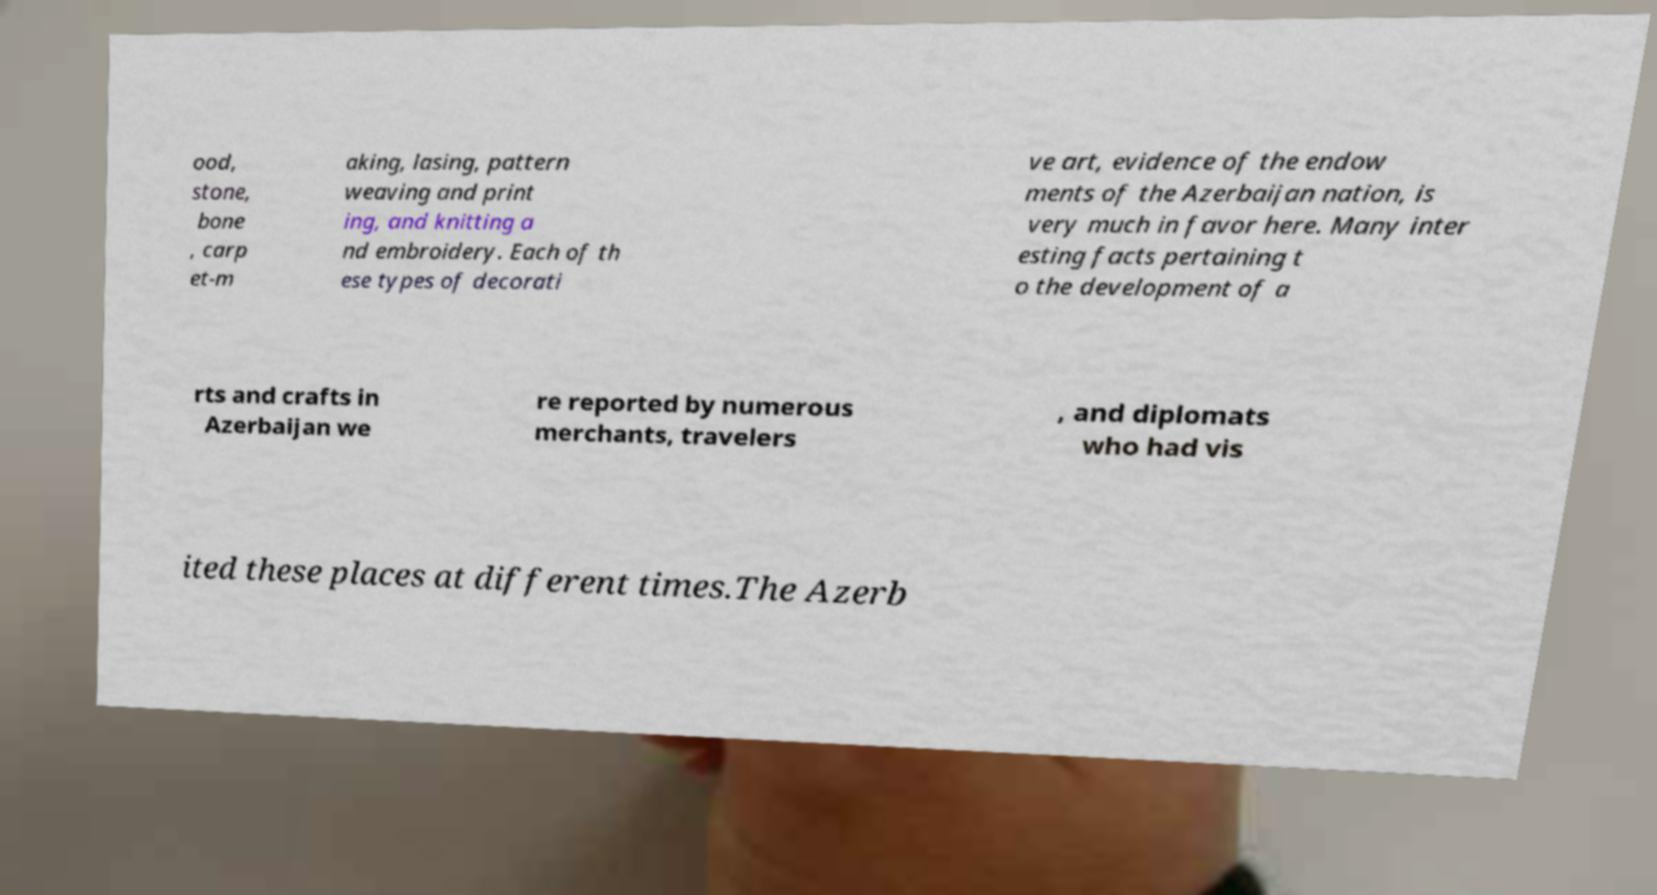Please read and relay the text visible in this image. What does it say? ood, stone, bone , carp et-m aking, lasing, pattern weaving and print ing, and knitting a nd embroidery. Each of th ese types of decorati ve art, evidence of the endow ments of the Azerbaijan nation, is very much in favor here. Many inter esting facts pertaining t o the development of a rts and crafts in Azerbaijan we re reported by numerous merchants, travelers , and diplomats who had vis ited these places at different times.The Azerb 